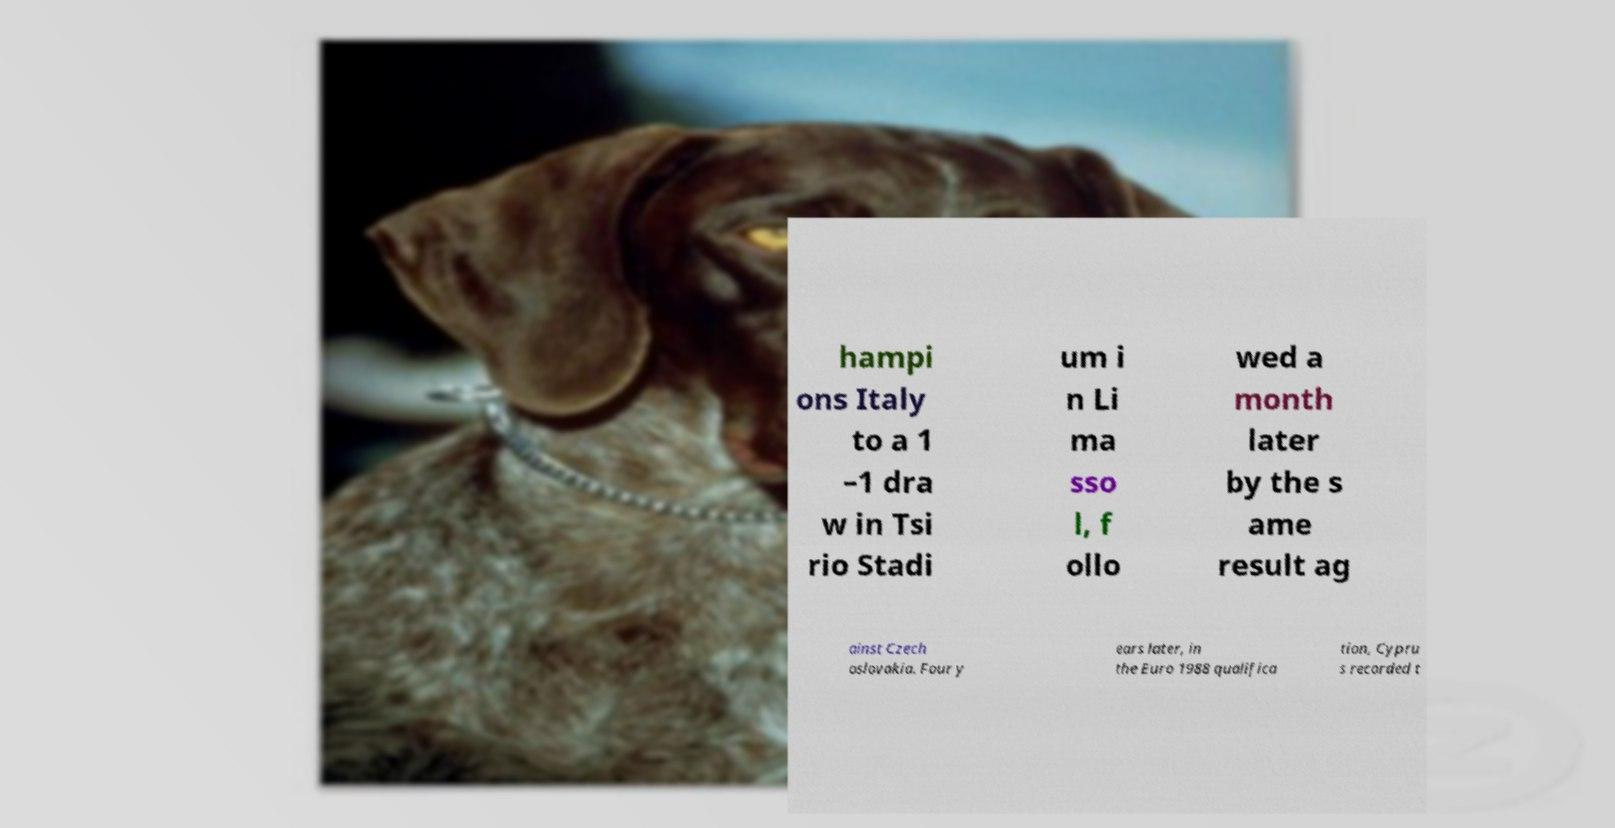Please identify and transcribe the text found in this image. hampi ons Italy to a 1 –1 dra w in Tsi rio Stadi um i n Li ma sso l, f ollo wed a month later by the s ame result ag ainst Czech oslovakia. Four y ears later, in the Euro 1988 qualifica tion, Cypru s recorded t 